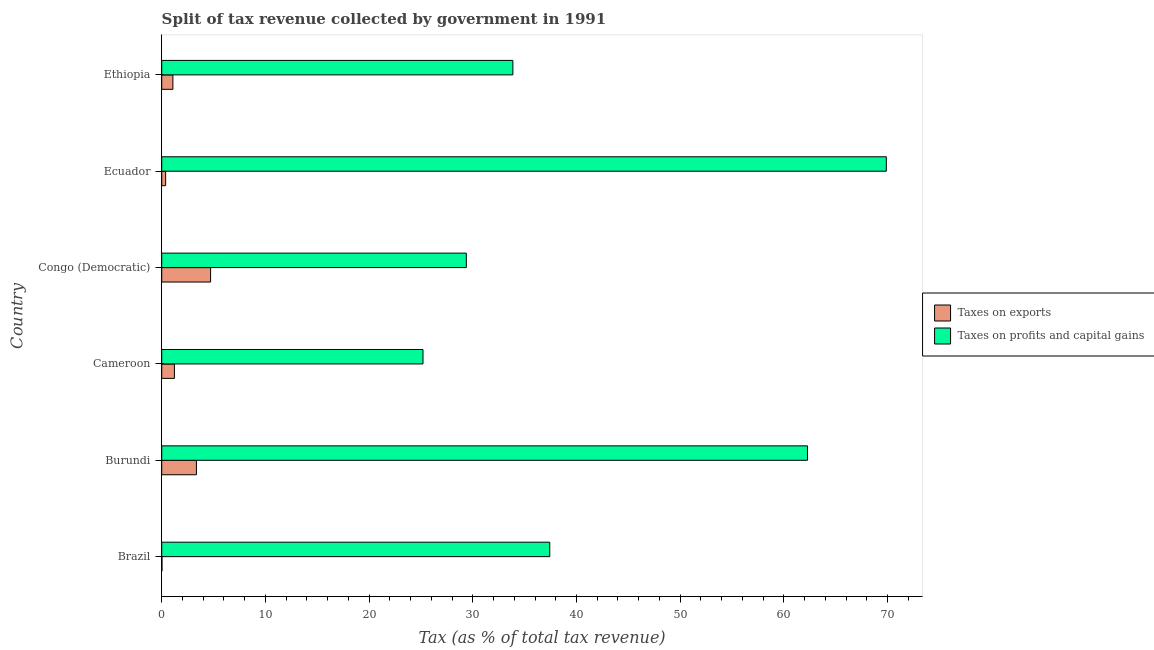How many groups of bars are there?
Keep it short and to the point. 6. Are the number of bars per tick equal to the number of legend labels?
Make the answer very short. Yes. How many bars are there on the 3rd tick from the top?
Offer a very short reply. 2. What is the label of the 1st group of bars from the top?
Provide a succinct answer. Ethiopia. What is the percentage of revenue obtained from taxes on profits and capital gains in Congo (Democratic)?
Provide a succinct answer. 29.38. Across all countries, what is the maximum percentage of revenue obtained from taxes on profits and capital gains?
Offer a terse response. 69.88. Across all countries, what is the minimum percentage of revenue obtained from taxes on profits and capital gains?
Offer a very short reply. 25.2. In which country was the percentage of revenue obtained from taxes on exports maximum?
Give a very brief answer. Congo (Democratic). In which country was the percentage of revenue obtained from taxes on exports minimum?
Offer a terse response. Brazil. What is the total percentage of revenue obtained from taxes on profits and capital gains in the graph?
Offer a very short reply. 258.01. What is the difference between the percentage of revenue obtained from taxes on exports in Congo (Democratic) and that in Ecuador?
Make the answer very short. 4.33. What is the difference between the percentage of revenue obtained from taxes on exports in Burundi and the percentage of revenue obtained from taxes on profits and capital gains in Congo (Democratic)?
Ensure brevity in your answer.  -26.03. What is the average percentage of revenue obtained from taxes on exports per country?
Your response must be concise. 1.79. What is the difference between the percentage of revenue obtained from taxes on profits and capital gains and percentage of revenue obtained from taxes on exports in Cameroon?
Your response must be concise. 23.97. In how many countries, is the percentage of revenue obtained from taxes on profits and capital gains greater than 70 %?
Ensure brevity in your answer.  0. What is the ratio of the percentage of revenue obtained from taxes on profits and capital gains in Brazil to that in Ethiopia?
Your answer should be very brief. 1.1. What is the difference between the highest and the second highest percentage of revenue obtained from taxes on exports?
Your response must be concise. 1.37. What is the difference between the highest and the lowest percentage of revenue obtained from taxes on exports?
Make the answer very short. 4.69. What does the 1st bar from the top in Brazil represents?
Provide a short and direct response. Taxes on profits and capital gains. What does the 1st bar from the bottom in Brazil represents?
Give a very brief answer. Taxes on exports. Are all the bars in the graph horizontal?
Offer a very short reply. Yes. What is the difference between two consecutive major ticks on the X-axis?
Offer a very short reply. 10. Are the values on the major ticks of X-axis written in scientific E-notation?
Keep it short and to the point. No. Where does the legend appear in the graph?
Offer a terse response. Center right. How are the legend labels stacked?
Keep it short and to the point. Vertical. What is the title of the graph?
Keep it short and to the point. Split of tax revenue collected by government in 1991. What is the label or title of the X-axis?
Ensure brevity in your answer.  Tax (as % of total tax revenue). What is the Tax (as % of total tax revenue) in Taxes on exports in Brazil?
Ensure brevity in your answer.  0.03. What is the Tax (as % of total tax revenue) in Taxes on profits and capital gains in Brazil?
Ensure brevity in your answer.  37.42. What is the Tax (as % of total tax revenue) in Taxes on exports in Burundi?
Keep it short and to the point. 3.35. What is the Tax (as % of total tax revenue) in Taxes on profits and capital gains in Burundi?
Keep it short and to the point. 62.28. What is the Tax (as % of total tax revenue) of Taxes on exports in Cameroon?
Make the answer very short. 1.22. What is the Tax (as % of total tax revenue) in Taxes on profits and capital gains in Cameroon?
Your answer should be very brief. 25.2. What is the Tax (as % of total tax revenue) of Taxes on exports in Congo (Democratic)?
Make the answer very short. 4.71. What is the Tax (as % of total tax revenue) in Taxes on profits and capital gains in Congo (Democratic)?
Keep it short and to the point. 29.38. What is the Tax (as % of total tax revenue) in Taxes on exports in Ecuador?
Provide a short and direct response. 0.38. What is the Tax (as % of total tax revenue) in Taxes on profits and capital gains in Ecuador?
Offer a very short reply. 69.88. What is the Tax (as % of total tax revenue) in Taxes on exports in Ethiopia?
Provide a short and direct response. 1.08. What is the Tax (as % of total tax revenue) of Taxes on profits and capital gains in Ethiopia?
Make the answer very short. 33.86. Across all countries, what is the maximum Tax (as % of total tax revenue) in Taxes on exports?
Your answer should be compact. 4.71. Across all countries, what is the maximum Tax (as % of total tax revenue) of Taxes on profits and capital gains?
Keep it short and to the point. 69.88. Across all countries, what is the minimum Tax (as % of total tax revenue) in Taxes on exports?
Your answer should be compact. 0.03. Across all countries, what is the minimum Tax (as % of total tax revenue) in Taxes on profits and capital gains?
Keep it short and to the point. 25.2. What is the total Tax (as % of total tax revenue) of Taxes on exports in the graph?
Your answer should be compact. 10.77. What is the total Tax (as % of total tax revenue) in Taxes on profits and capital gains in the graph?
Your response must be concise. 258.01. What is the difference between the Tax (as % of total tax revenue) in Taxes on exports in Brazil and that in Burundi?
Ensure brevity in your answer.  -3.32. What is the difference between the Tax (as % of total tax revenue) in Taxes on profits and capital gains in Brazil and that in Burundi?
Your response must be concise. -24.85. What is the difference between the Tax (as % of total tax revenue) of Taxes on exports in Brazil and that in Cameroon?
Your response must be concise. -1.2. What is the difference between the Tax (as % of total tax revenue) of Taxes on profits and capital gains in Brazil and that in Cameroon?
Make the answer very short. 12.22. What is the difference between the Tax (as % of total tax revenue) in Taxes on exports in Brazil and that in Congo (Democratic)?
Offer a terse response. -4.69. What is the difference between the Tax (as % of total tax revenue) in Taxes on profits and capital gains in Brazil and that in Congo (Democratic)?
Keep it short and to the point. 8.05. What is the difference between the Tax (as % of total tax revenue) of Taxes on exports in Brazil and that in Ecuador?
Give a very brief answer. -0.35. What is the difference between the Tax (as % of total tax revenue) in Taxes on profits and capital gains in Brazil and that in Ecuador?
Make the answer very short. -32.46. What is the difference between the Tax (as % of total tax revenue) of Taxes on exports in Brazil and that in Ethiopia?
Keep it short and to the point. -1.05. What is the difference between the Tax (as % of total tax revenue) of Taxes on profits and capital gains in Brazil and that in Ethiopia?
Offer a very short reply. 3.56. What is the difference between the Tax (as % of total tax revenue) of Taxes on exports in Burundi and that in Cameroon?
Ensure brevity in your answer.  2.12. What is the difference between the Tax (as % of total tax revenue) in Taxes on profits and capital gains in Burundi and that in Cameroon?
Ensure brevity in your answer.  37.08. What is the difference between the Tax (as % of total tax revenue) of Taxes on exports in Burundi and that in Congo (Democratic)?
Make the answer very short. -1.37. What is the difference between the Tax (as % of total tax revenue) of Taxes on profits and capital gains in Burundi and that in Congo (Democratic)?
Ensure brevity in your answer.  32.9. What is the difference between the Tax (as % of total tax revenue) of Taxes on exports in Burundi and that in Ecuador?
Make the answer very short. 2.97. What is the difference between the Tax (as % of total tax revenue) in Taxes on profits and capital gains in Burundi and that in Ecuador?
Keep it short and to the point. -7.6. What is the difference between the Tax (as % of total tax revenue) in Taxes on exports in Burundi and that in Ethiopia?
Offer a terse response. 2.27. What is the difference between the Tax (as % of total tax revenue) of Taxes on profits and capital gains in Burundi and that in Ethiopia?
Make the answer very short. 28.41. What is the difference between the Tax (as % of total tax revenue) in Taxes on exports in Cameroon and that in Congo (Democratic)?
Your answer should be compact. -3.49. What is the difference between the Tax (as % of total tax revenue) of Taxes on profits and capital gains in Cameroon and that in Congo (Democratic)?
Give a very brief answer. -4.18. What is the difference between the Tax (as % of total tax revenue) of Taxes on exports in Cameroon and that in Ecuador?
Give a very brief answer. 0.84. What is the difference between the Tax (as % of total tax revenue) in Taxes on profits and capital gains in Cameroon and that in Ecuador?
Your answer should be compact. -44.68. What is the difference between the Tax (as % of total tax revenue) in Taxes on exports in Cameroon and that in Ethiopia?
Your answer should be very brief. 0.14. What is the difference between the Tax (as % of total tax revenue) of Taxes on profits and capital gains in Cameroon and that in Ethiopia?
Your answer should be very brief. -8.67. What is the difference between the Tax (as % of total tax revenue) in Taxes on exports in Congo (Democratic) and that in Ecuador?
Ensure brevity in your answer.  4.33. What is the difference between the Tax (as % of total tax revenue) in Taxes on profits and capital gains in Congo (Democratic) and that in Ecuador?
Make the answer very short. -40.5. What is the difference between the Tax (as % of total tax revenue) in Taxes on exports in Congo (Democratic) and that in Ethiopia?
Keep it short and to the point. 3.63. What is the difference between the Tax (as % of total tax revenue) in Taxes on profits and capital gains in Congo (Democratic) and that in Ethiopia?
Ensure brevity in your answer.  -4.49. What is the difference between the Tax (as % of total tax revenue) in Taxes on exports in Ecuador and that in Ethiopia?
Keep it short and to the point. -0.7. What is the difference between the Tax (as % of total tax revenue) in Taxes on profits and capital gains in Ecuador and that in Ethiopia?
Keep it short and to the point. 36.01. What is the difference between the Tax (as % of total tax revenue) in Taxes on exports in Brazil and the Tax (as % of total tax revenue) in Taxes on profits and capital gains in Burundi?
Your answer should be compact. -62.25. What is the difference between the Tax (as % of total tax revenue) of Taxes on exports in Brazil and the Tax (as % of total tax revenue) of Taxes on profits and capital gains in Cameroon?
Offer a very short reply. -25.17. What is the difference between the Tax (as % of total tax revenue) of Taxes on exports in Brazil and the Tax (as % of total tax revenue) of Taxes on profits and capital gains in Congo (Democratic)?
Ensure brevity in your answer.  -29.35. What is the difference between the Tax (as % of total tax revenue) in Taxes on exports in Brazil and the Tax (as % of total tax revenue) in Taxes on profits and capital gains in Ecuador?
Offer a very short reply. -69.85. What is the difference between the Tax (as % of total tax revenue) in Taxes on exports in Brazil and the Tax (as % of total tax revenue) in Taxes on profits and capital gains in Ethiopia?
Offer a very short reply. -33.84. What is the difference between the Tax (as % of total tax revenue) in Taxes on exports in Burundi and the Tax (as % of total tax revenue) in Taxes on profits and capital gains in Cameroon?
Give a very brief answer. -21.85. What is the difference between the Tax (as % of total tax revenue) in Taxes on exports in Burundi and the Tax (as % of total tax revenue) in Taxes on profits and capital gains in Congo (Democratic)?
Offer a terse response. -26.03. What is the difference between the Tax (as % of total tax revenue) of Taxes on exports in Burundi and the Tax (as % of total tax revenue) of Taxes on profits and capital gains in Ecuador?
Keep it short and to the point. -66.53. What is the difference between the Tax (as % of total tax revenue) of Taxes on exports in Burundi and the Tax (as % of total tax revenue) of Taxes on profits and capital gains in Ethiopia?
Offer a terse response. -30.52. What is the difference between the Tax (as % of total tax revenue) of Taxes on exports in Cameroon and the Tax (as % of total tax revenue) of Taxes on profits and capital gains in Congo (Democratic)?
Keep it short and to the point. -28.15. What is the difference between the Tax (as % of total tax revenue) of Taxes on exports in Cameroon and the Tax (as % of total tax revenue) of Taxes on profits and capital gains in Ecuador?
Your answer should be very brief. -68.66. What is the difference between the Tax (as % of total tax revenue) of Taxes on exports in Cameroon and the Tax (as % of total tax revenue) of Taxes on profits and capital gains in Ethiopia?
Your answer should be very brief. -32.64. What is the difference between the Tax (as % of total tax revenue) in Taxes on exports in Congo (Democratic) and the Tax (as % of total tax revenue) in Taxes on profits and capital gains in Ecuador?
Ensure brevity in your answer.  -65.17. What is the difference between the Tax (as % of total tax revenue) of Taxes on exports in Congo (Democratic) and the Tax (as % of total tax revenue) of Taxes on profits and capital gains in Ethiopia?
Provide a succinct answer. -29.15. What is the difference between the Tax (as % of total tax revenue) in Taxes on exports in Ecuador and the Tax (as % of total tax revenue) in Taxes on profits and capital gains in Ethiopia?
Give a very brief answer. -33.48. What is the average Tax (as % of total tax revenue) in Taxes on exports per country?
Your answer should be very brief. 1.79. What is the average Tax (as % of total tax revenue) of Taxes on profits and capital gains per country?
Your response must be concise. 43. What is the difference between the Tax (as % of total tax revenue) in Taxes on exports and Tax (as % of total tax revenue) in Taxes on profits and capital gains in Brazil?
Provide a short and direct response. -37.4. What is the difference between the Tax (as % of total tax revenue) of Taxes on exports and Tax (as % of total tax revenue) of Taxes on profits and capital gains in Burundi?
Make the answer very short. -58.93. What is the difference between the Tax (as % of total tax revenue) of Taxes on exports and Tax (as % of total tax revenue) of Taxes on profits and capital gains in Cameroon?
Ensure brevity in your answer.  -23.97. What is the difference between the Tax (as % of total tax revenue) of Taxes on exports and Tax (as % of total tax revenue) of Taxes on profits and capital gains in Congo (Democratic)?
Keep it short and to the point. -24.66. What is the difference between the Tax (as % of total tax revenue) of Taxes on exports and Tax (as % of total tax revenue) of Taxes on profits and capital gains in Ecuador?
Your response must be concise. -69.5. What is the difference between the Tax (as % of total tax revenue) of Taxes on exports and Tax (as % of total tax revenue) of Taxes on profits and capital gains in Ethiopia?
Make the answer very short. -32.79. What is the ratio of the Tax (as % of total tax revenue) in Taxes on exports in Brazil to that in Burundi?
Your response must be concise. 0.01. What is the ratio of the Tax (as % of total tax revenue) of Taxes on profits and capital gains in Brazil to that in Burundi?
Ensure brevity in your answer.  0.6. What is the ratio of the Tax (as % of total tax revenue) in Taxes on exports in Brazil to that in Cameroon?
Provide a short and direct response. 0.02. What is the ratio of the Tax (as % of total tax revenue) in Taxes on profits and capital gains in Brazil to that in Cameroon?
Make the answer very short. 1.49. What is the ratio of the Tax (as % of total tax revenue) of Taxes on exports in Brazil to that in Congo (Democratic)?
Ensure brevity in your answer.  0.01. What is the ratio of the Tax (as % of total tax revenue) in Taxes on profits and capital gains in Brazil to that in Congo (Democratic)?
Keep it short and to the point. 1.27. What is the ratio of the Tax (as % of total tax revenue) of Taxes on exports in Brazil to that in Ecuador?
Provide a succinct answer. 0.07. What is the ratio of the Tax (as % of total tax revenue) in Taxes on profits and capital gains in Brazil to that in Ecuador?
Make the answer very short. 0.54. What is the ratio of the Tax (as % of total tax revenue) in Taxes on exports in Brazil to that in Ethiopia?
Your answer should be very brief. 0.02. What is the ratio of the Tax (as % of total tax revenue) of Taxes on profits and capital gains in Brazil to that in Ethiopia?
Ensure brevity in your answer.  1.11. What is the ratio of the Tax (as % of total tax revenue) in Taxes on exports in Burundi to that in Cameroon?
Keep it short and to the point. 2.74. What is the ratio of the Tax (as % of total tax revenue) of Taxes on profits and capital gains in Burundi to that in Cameroon?
Provide a short and direct response. 2.47. What is the ratio of the Tax (as % of total tax revenue) of Taxes on exports in Burundi to that in Congo (Democratic)?
Offer a terse response. 0.71. What is the ratio of the Tax (as % of total tax revenue) in Taxes on profits and capital gains in Burundi to that in Congo (Democratic)?
Ensure brevity in your answer.  2.12. What is the ratio of the Tax (as % of total tax revenue) of Taxes on exports in Burundi to that in Ecuador?
Provide a succinct answer. 8.81. What is the ratio of the Tax (as % of total tax revenue) in Taxes on profits and capital gains in Burundi to that in Ecuador?
Make the answer very short. 0.89. What is the ratio of the Tax (as % of total tax revenue) of Taxes on exports in Burundi to that in Ethiopia?
Your answer should be compact. 3.1. What is the ratio of the Tax (as % of total tax revenue) in Taxes on profits and capital gains in Burundi to that in Ethiopia?
Offer a terse response. 1.84. What is the ratio of the Tax (as % of total tax revenue) in Taxes on exports in Cameroon to that in Congo (Democratic)?
Provide a succinct answer. 0.26. What is the ratio of the Tax (as % of total tax revenue) of Taxes on profits and capital gains in Cameroon to that in Congo (Democratic)?
Your answer should be very brief. 0.86. What is the ratio of the Tax (as % of total tax revenue) of Taxes on exports in Cameroon to that in Ecuador?
Make the answer very short. 3.22. What is the ratio of the Tax (as % of total tax revenue) of Taxes on profits and capital gains in Cameroon to that in Ecuador?
Keep it short and to the point. 0.36. What is the ratio of the Tax (as % of total tax revenue) in Taxes on exports in Cameroon to that in Ethiopia?
Provide a short and direct response. 1.13. What is the ratio of the Tax (as % of total tax revenue) in Taxes on profits and capital gains in Cameroon to that in Ethiopia?
Your answer should be very brief. 0.74. What is the ratio of the Tax (as % of total tax revenue) in Taxes on exports in Congo (Democratic) to that in Ecuador?
Your answer should be compact. 12.4. What is the ratio of the Tax (as % of total tax revenue) in Taxes on profits and capital gains in Congo (Democratic) to that in Ecuador?
Give a very brief answer. 0.42. What is the ratio of the Tax (as % of total tax revenue) of Taxes on exports in Congo (Democratic) to that in Ethiopia?
Your response must be concise. 4.37. What is the ratio of the Tax (as % of total tax revenue) of Taxes on profits and capital gains in Congo (Democratic) to that in Ethiopia?
Give a very brief answer. 0.87. What is the ratio of the Tax (as % of total tax revenue) in Taxes on exports in Ecuador to that in Ethiopia?
Offer a very short reply. 0.35. What is the ratio of the Tax (as % of total tax revenue) in Taxes on profits and capital gains in Ecuador to that in Ethiopia?
Ensure brevity in your answer.  2.06. What is the difference between the highest and the second highest Tax (as % of total tax revenue) of Taxes on exports?
Ensure brevity in your answer.  1.37. What is the difference between the highest and the second highest Tax (as % of total tax revenue) in Taxes on profits and capital gains?
Keep it short and to the point. 7.6. What is the difference between the highest and the lowest Tax (as % of total tax revenue) in Taxes on exports?
Your response must be concise. 4.69. What is the difference between the highest and the lowest Tax (as % of total tax revenue) in Taxes on profits and capital gains?
Keep it short and to the point. 44.68. 